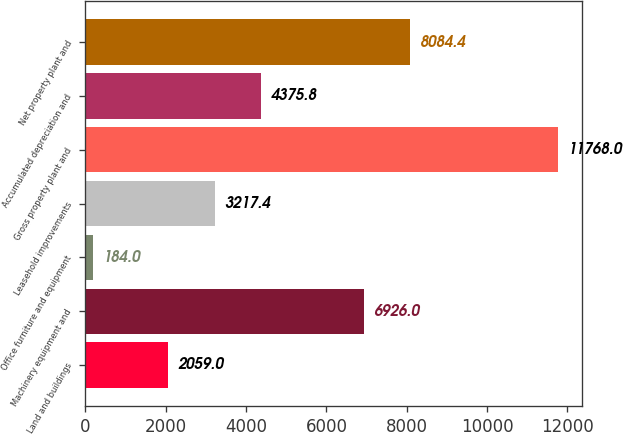Convert chart to OTSL. <chart><loc_0><loc_0><loc_500><loc_500><bar_chart><fcel>Land and buildings<fcel>Machinery equipment and<fcel>Office furniture and equipment<fcel>Leasehold improvements<fcel>Gross property plant and<fcel>Accumulated depreciation and<fcel>Net property plant and<nl><fcel>2059<fcel>6926<fcel>184<fcel>3217.4<fcel>11768<fcel>4375.8<fcel>8084.4<nl></chart> 